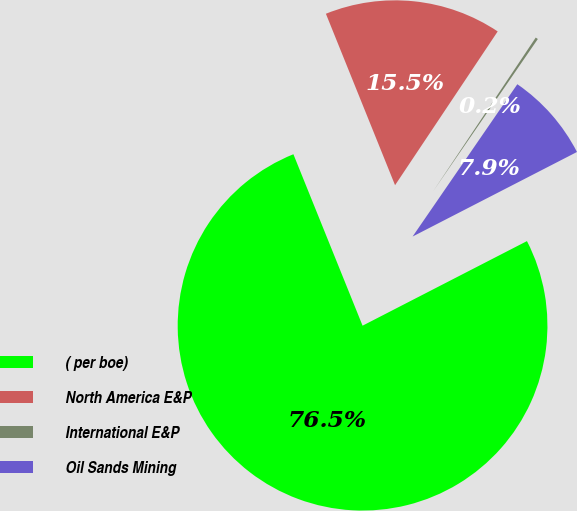Convert chart to OTSL. <chart><loc_0><loc_0><loc_500><loc_500><pie_chart><fcel>( per boe)<fcel>North America E&P<fcel>International E&P<fcel>Oil Sands Mining<nl><fcel>76.46%<fcel>15.47%<fcel>0.22%<fcel>7.85%<nl></chart> 